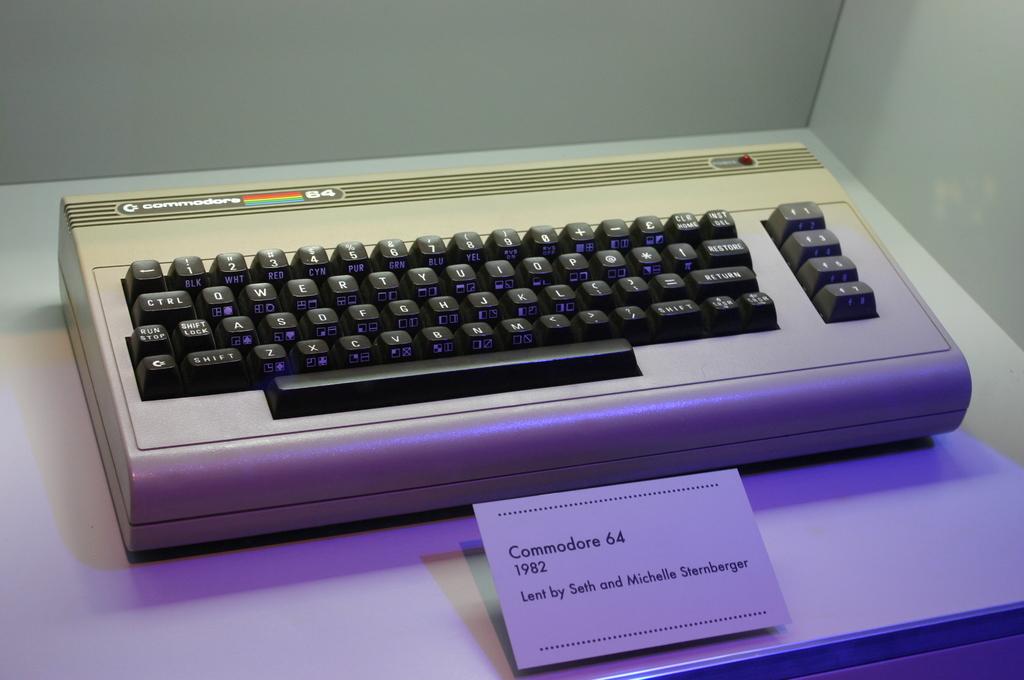What is the name of the computer?
Offer a terse response. Commodore 64. 